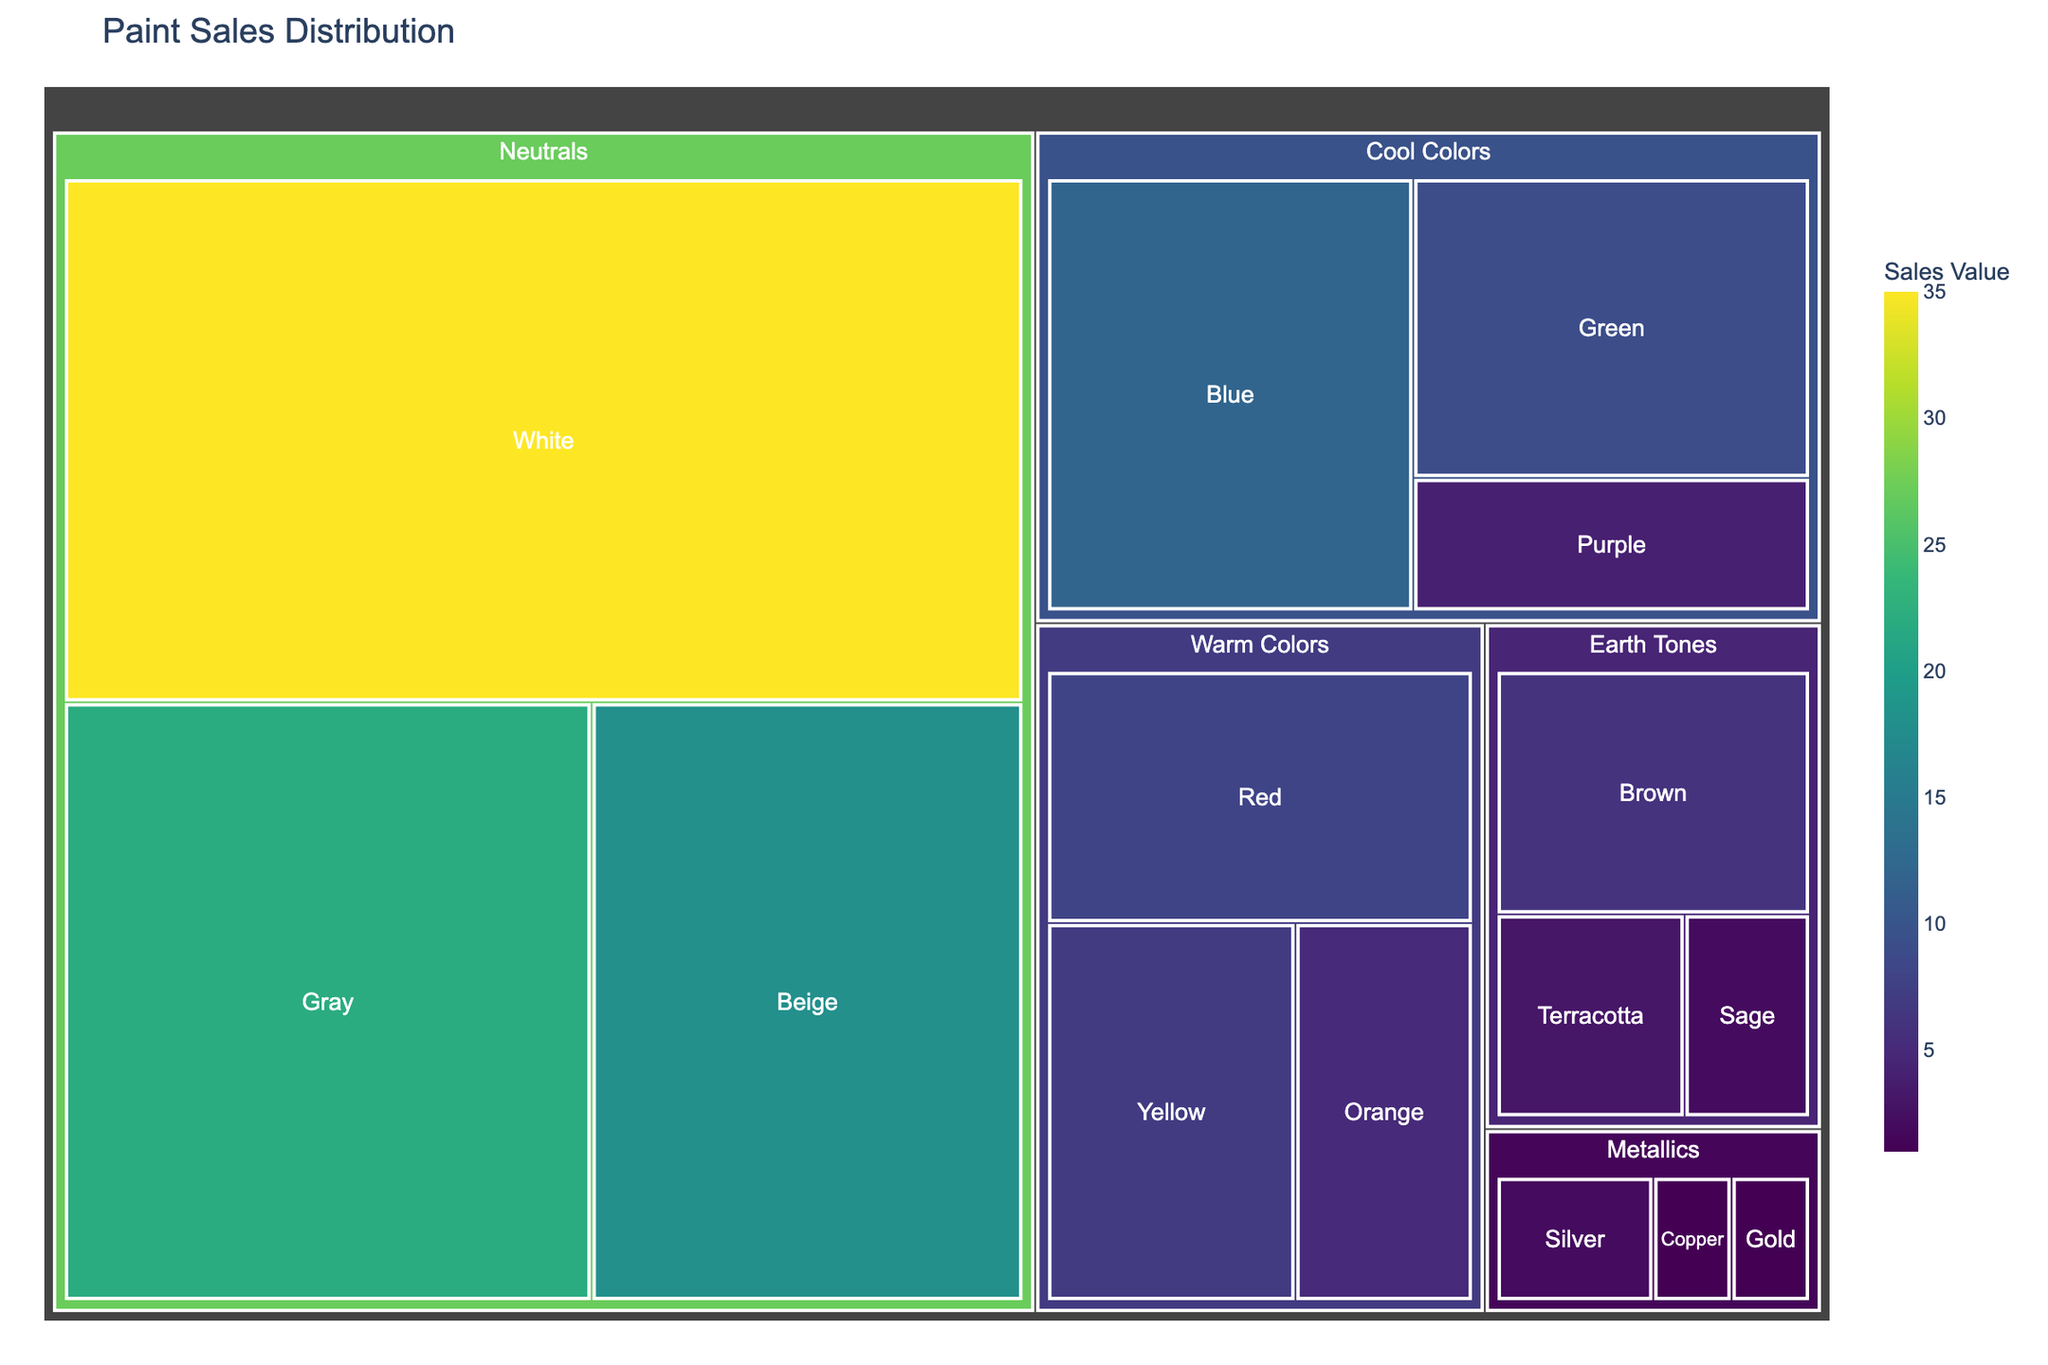Which color category has the highest paint sales? The treemap shows color categories and their corresponding paint sales. By examining the largest areas, the "Neutrals" category stands out as having the highest sales.
Answer: Neutrals What is the total sales value for the "Warm Colors" category? Summing up the values for all subcategories under "Warm Colors": Red (8) + Orange (5) + Yellow (7) = 20.
Answer: 20 Which shade within "Cool Colors" has the lowest sales value? Looking at the subcategories within "Cool Colors," we see Blue (12), Green (9), and Purple (4). Purple has the lowest sales value.
Answer: Purple How does the sales value of "Gray" compare to "Blue"? The sales values for "Gray" and "Blue" are 22 and 12, respectively. Compare these values to see that "Gray" has higher sales than "Blue."
Answer: Gray has higher sales What is the combined sales value of all shades under "Metallics"? The "Metallics" category includes Silver (2), Gold (1), and Copper (1). Adding these values gives 2 + 1 + 1 = 4.
Answer: 4 Which category has the highest number of subcategories? Count the subcategories under each category: Neutrals (3), Warm Colors (3), Cool Colors (3), Earth Tones (3), Metallics (3). All categories have the same number of subcategories.
Answer: All categories have the same number What is the average sales value for the "Earth Tones" category? Sum the sales values of Brown (6), Terracotta (3), and Sage (2), which is 6 + 3 + 2 = 11. The average is 11/3 = 3.67 (rounded to two decimal places).
Answer: 3.67 Compare the total sales values between "Neutrals" and "Earth Tones". The total for "Neutrals" is White (35) + Beige (18) + Gray (22) = 75. The total for "Earth Tones" is Brown (6) + Terracotta (3) + Sage (2) = 11. Comparing these totals shows "Neutrals" have much higher sales.
Answer: Neutrals have higher sales Which subcategory has the highest sales value across all categories? Examine all the subcategories and their values. "White" in the "Neutrals" category has the highest sales value with 35.
Answer: White 